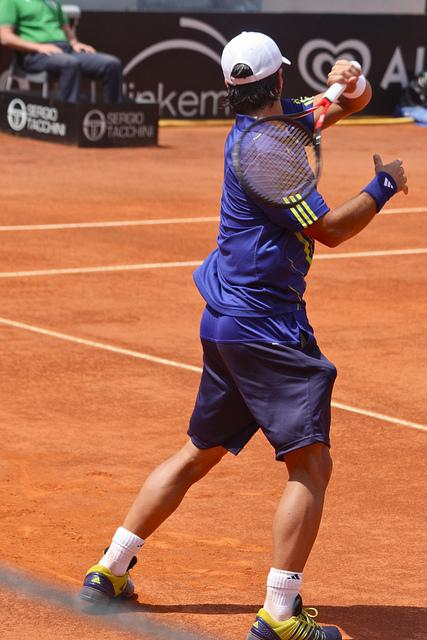What move does this player use? backhand 